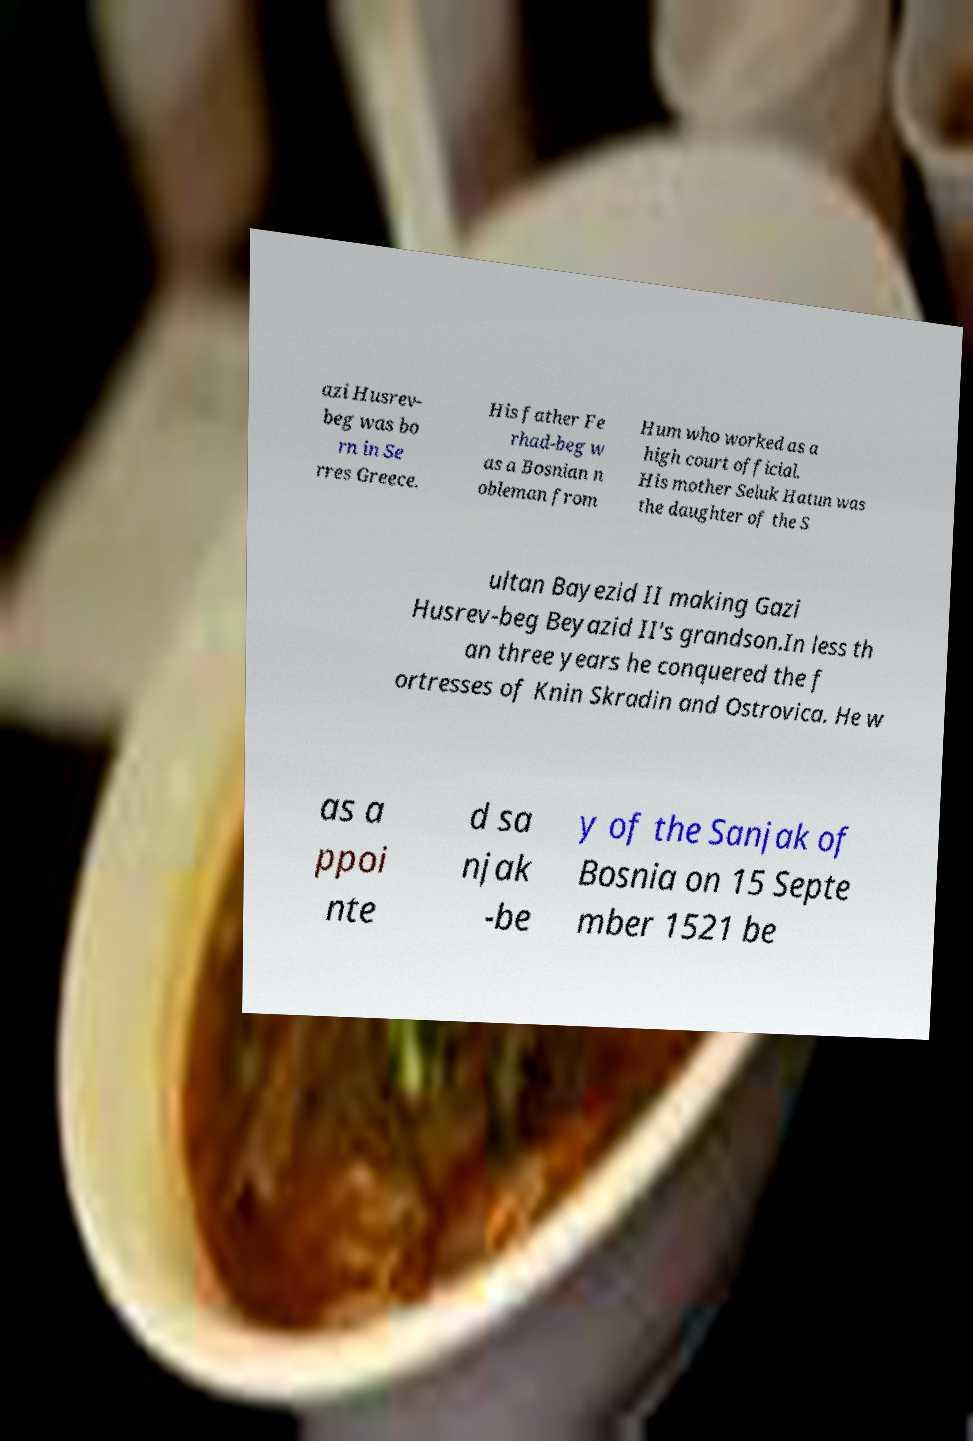Could you extract and type out the text from this image? azi Husrev- beg was bo rn in Se rres Greece. His father Fe rhad-beg w as a Bosnian n obleman from Hum who worked as a high court official. His mother Seluk Hatun was the daughter of the S ultan Bayezid II making Gazi Husrev-beg Beyazid II's grandson.In less th an three years he conquered the f ortresses of Knin Skradin and Ostrovica. He w as a ppoi nte d sa njak -be y of the Sanjak of Bosnia on 15 Septe mber 1521 be 